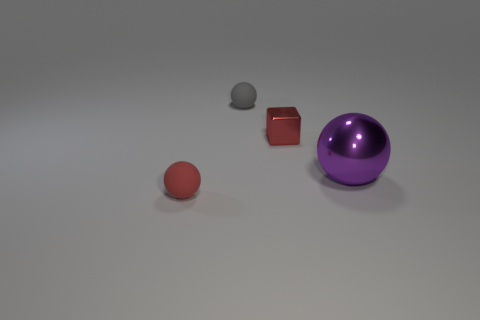Is there any other thing that has the same material as the large sphere?
Give a very brief answer. Yes. How many other objects are the same shape as the purple object?
Make the answer very short. 2. How many big blue rubber cylinders are there?
Make the answer very short. 0. How many spheres are either gray matte things or tiny red metallic objects?
Your response must be concise. 1. There is a tiny matte thing that is behind the large object; what number of small things are to the right of it?
Your answer should be very brief. 1. Do the tiny red cube and the big purple thing have the same material?
Make the answer very short. Yes. What size is the thing that is the same color as the cube?
Offer a very short reply. Small. Are there any blocks made of the same material as the purple object?
Your response must be concise. Yes. There is a small rubber object in front of the big object behind the tiny ball on the left side of the gray sphere; what color is it?
Ensure brevity in your answer.  Red. How many red things are large objects or balls?
Keep it short and to the point. 1. 